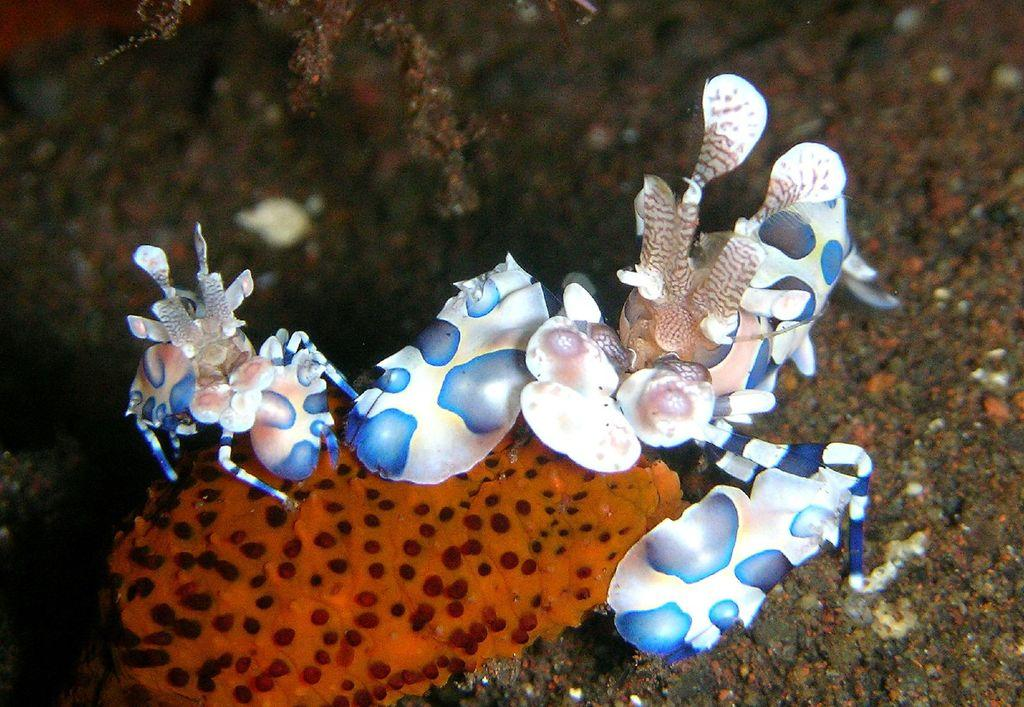What type of objects can be seen in the water in the image? There are white color shells in the water in the image. Are there any shells with a different color in the image? Yes, there is an orange color shell in the image. What else can be seen in the image besides shells? There is a plant in the image. How would you describe the background of the image? The background of the image is blurred. What type of cart does the father use to attempt to collect the shells in the image? There is no father, cart, or attempt to collect shells present in the image. 